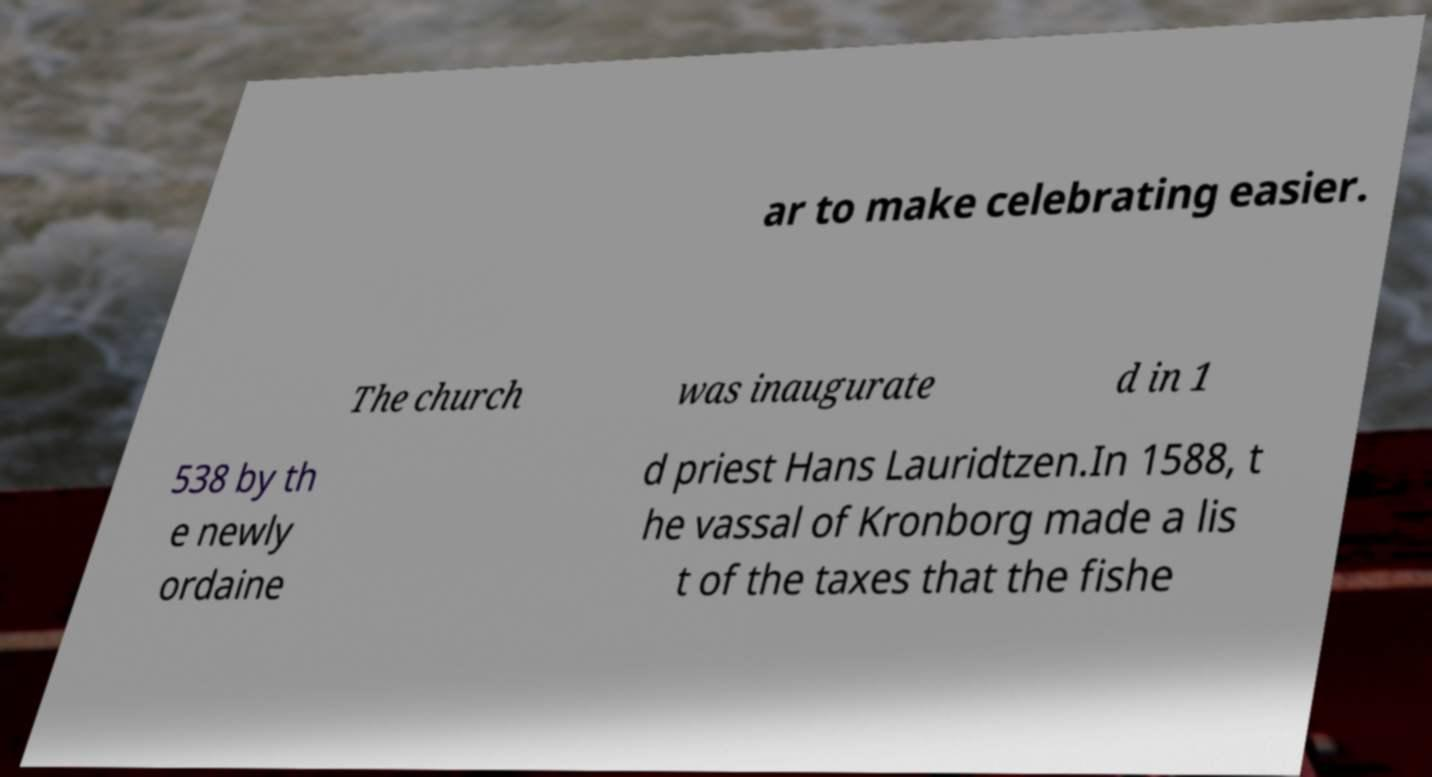What messages or text are displayed in this image? I need them in a readable, typed format. ar to make celebrating easier. The church was inaugurate d in 1 538 by th e newly ordaine d priest Hans Lauridtzen.In 1588, t he vassal of Kronborg made a lis t of the taxes that the fishe 